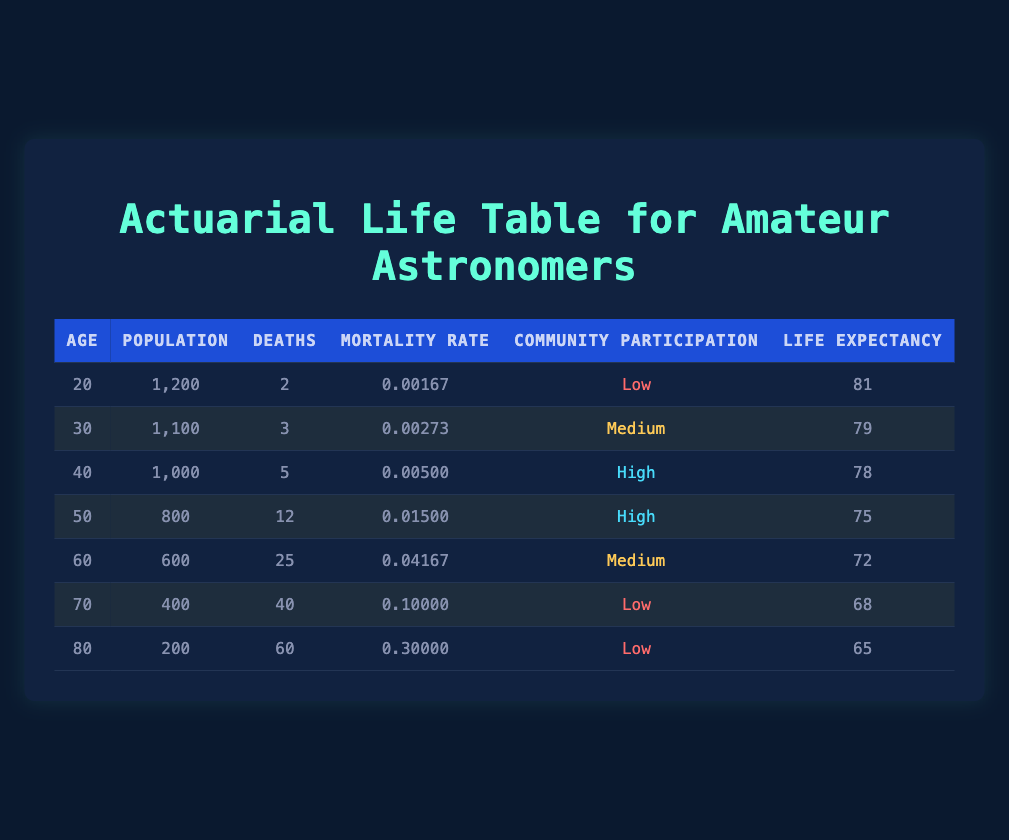What is the mortality rate for amateur astronomers aged 40? The table shows the mortality rate in the column labeled "Mortality Rate" for the row where "Age" is 40. It displays a value of 0.00500.
Answer: 0.00500 What is the life expectancy for amateur astronomers aged 50? Looking at the "Life Expectancy" column in the row corresponding to age 50, it indicates a life expectancy of 75 years.
Answer: 75 Which age group has the highest mortality rate? The highest mortality rate can be found by comparing the values in the "Mortality Rate" column across all age groups. Age 80 has the highest rate at 0.30000.
Answer: Age 80 What is the average life expectancy of amateur astronomers who participate in community events at a high level? To find the average, we look at the life expectancy of age groups with "High" community participation, which are ages 40 and 50. Their life expectancies are 78 and 75. Summing these gives 153, and averaging gives 153 / 2 = 76.5.
Answer: 76.5 Is it true that the mortality rate increases with age for amateur astronomers? By examining the table, we observe that as age increases (from 20 to 80), the mortality rates also show an increasing trend: 0.00167, 0.00273, 0.00500, 0.01500, 0.04167, 0.10000, and 0.30000. This indicates that the statement is true.
Answer: Yes What is the total number of deaths for amateur astronomers aged 60 and above? We need to sum the "Deaths" column for ages 60, 70, and 80. The values are 25 (age 60) + 40 (age 70) + 60 (age 80), which totals 125.
Answer: 125 How many amateur astronomers aged 30 participated in community activities? The "Population" column for those aged 30 indicates there are 1100 amateur astronomers, all of whom participated in community activities at a medium level.
Answer: 1100 What is the difference in mortality rates between those aged 20 and those aged 70? We compare the mortality rate for age 20 (0.00167) with that for age 70 (0.10000). The difference is 0.10000 - 0.00167 = 0.09833.
Answer: 0.09833 